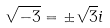Convert formula to latex. <formula><loc_0><loc_0><loc_500><loc_500>\sqrt { - 3 } = \pm \sqrt { 3 } i</formula> 